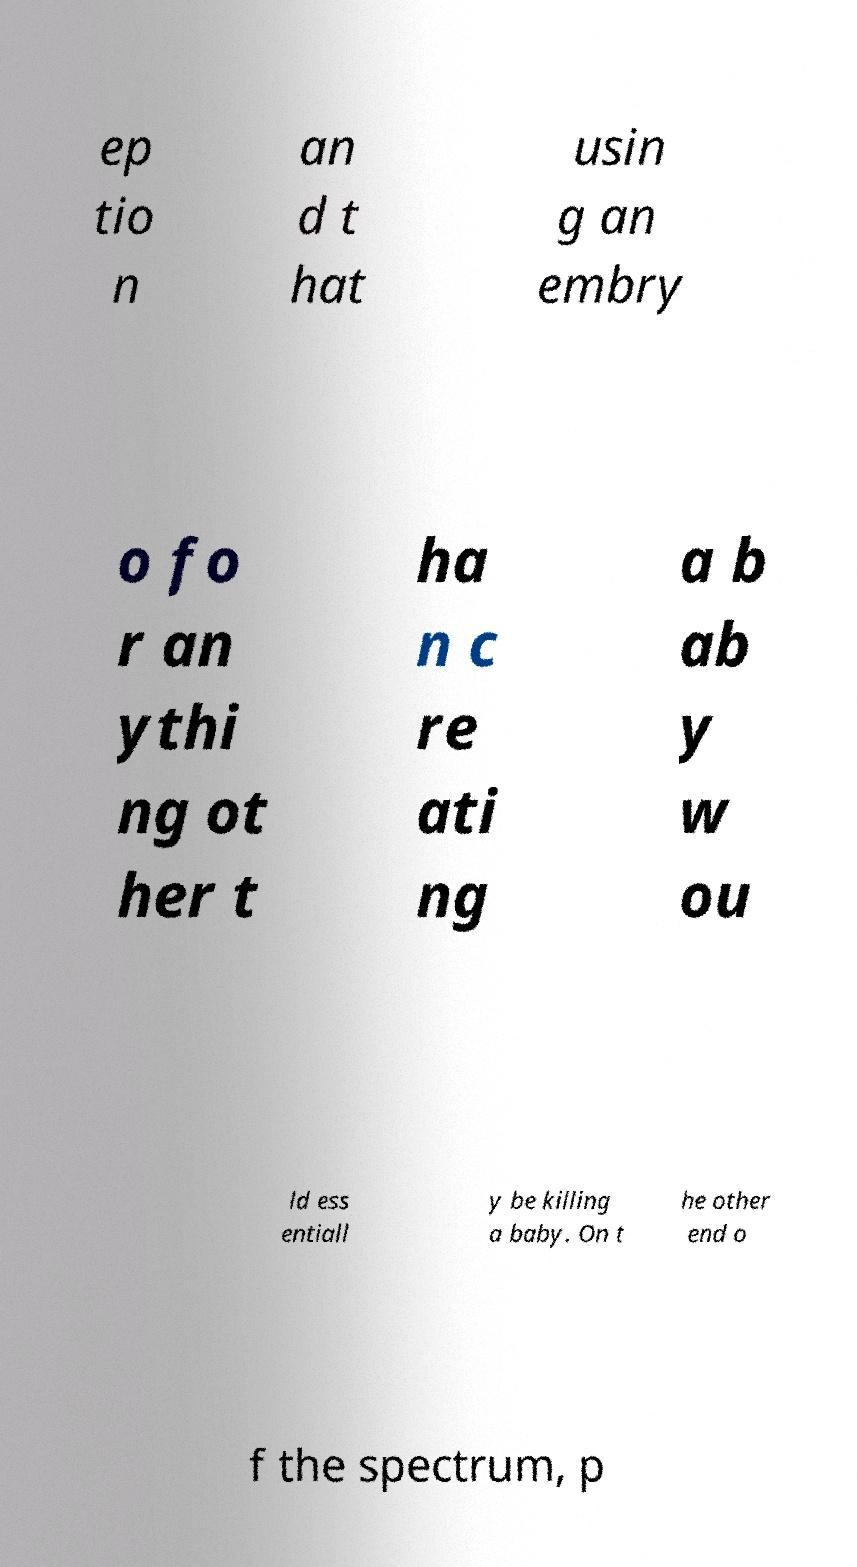Please identify and transcribe the text found in this image. ep tio n an d t hat usin g an embry o fo r an ythi ng ot her t ha n c re ati ng a b ab y w ou ld ess entiall y be killing a baby. On t he other end o f the spectrum, p 